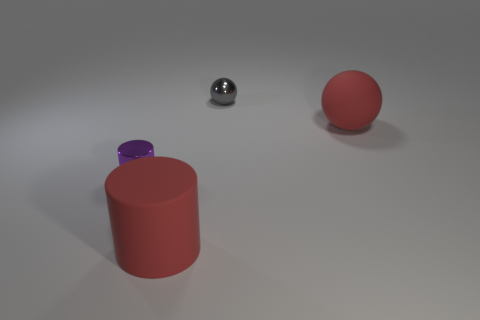Could you tell me the position of the objects in relation to each other? Certainly! Starting from the left side of the image, the purple cylinder is at the forefront. Behind it, toward the center, there's a small glossy ball, and to the right, there's a matte red ball. 